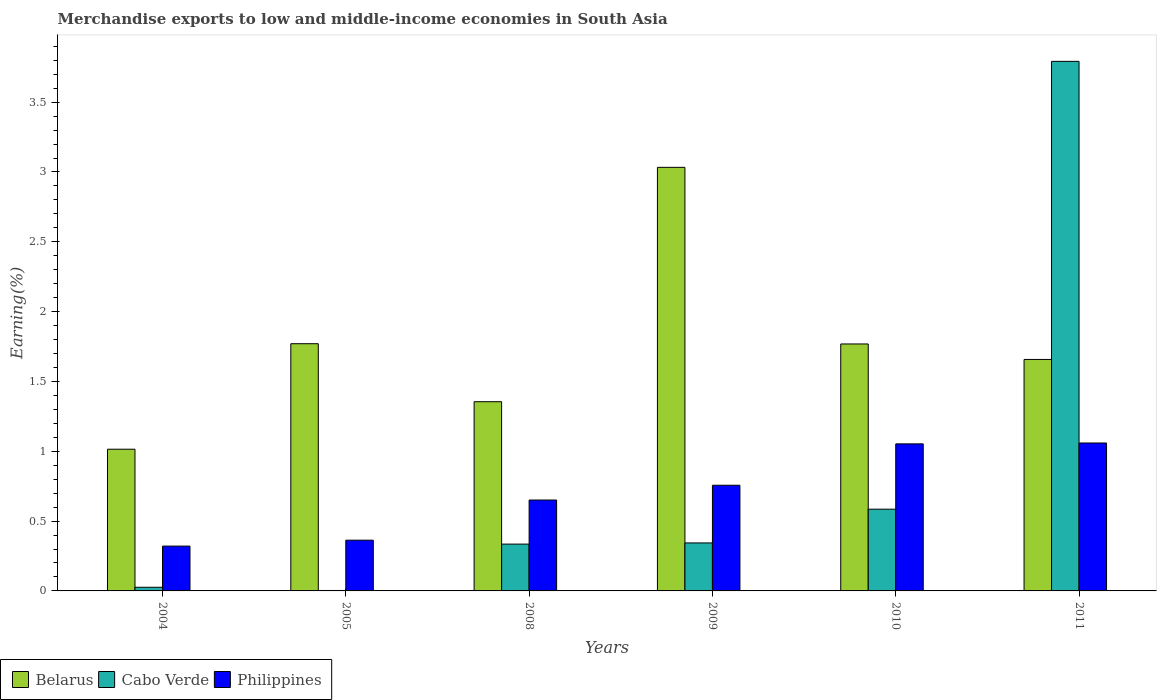How many different coloured bars are there?
Your answer should be compact. 3. Are the number of bars on each tick of the X-axis equal?
Provide a short and direct response. Yes. How many bars are there on the 1st tick from the right?
Provide a short and direct response. 3. In how many cases, is the number of bars for a given year not equal to the number of legend labels?
Make the answer very short. 0. What is the percentage of amount earned from merchandise exports in Cabo Verde in 2008?
Your answer should be very brief. 0.34. Across all years, what is the maximum percentage of amount earned from merchandise exports in Philippines?
Provide a succinct answer. 1.06. Across all years, what is the minimum percentage of amount earned from merchandise exports in Belarus?
Your response must be concise. 1.01. In which year was the percentage of amount earned from merchandise exports in Belarus maximum?
Your answer should be compact. 2009. What is the total percentage of amount earned from merchandise exports in Philippines in the graph?
Ensure brevity in your answer.  4.2. What is the difference between the percentage of amount earned from merchandise exports in Belarus in 2008 and that in 2009?
Provide a succinct answer. -1.68. What is the difference between the percentage of amount earned from merchandise exports in Belarus in 2009 and the percentage of amount earned from merchandise exports in Philippines in 2004?
Keep it short and to the point. 2.71. What is the average percentage of amount earned from merchandise exports in Cabo Verde per year?
Keep it short and to the point. 0.85. In the year 2011, what is the difference between the percentage of amount earned from merchandise exports in Cabo Verde and percentage of amount earned from merchandise exports in Belarus?
Your response must be concise. 2.13. In how many years, is the percentage of amount earned from merchandise exports in Philippines greater than 2.4 %?
Provide a short and direct response. 0. What is the ratio of the percentage of amount earned from merchandise exports in Philippines in 2008 to that in 2011?
Provide a short and direct response. 0.61. Is the difference between the percentage of amount earned from merchandise exports in Cabo Verde in 2005 and 2008 greater than the difference between the percentage of amount earned from merchandise exports in Belarus in 2005 and 2008?
Provide a succinct answer. No. What is the difference between the highest and the second highest percentage of amount earned from merchandise exports in Philippines?
Provide a succinct answer. 0.01. What is the difference between the highest and the lowest percentage of amount earned from merchandise exports in Belarus?
Your answer should be very brief. 2.02. What does the 2nd bar from the left in 2009 represents?
Ensure brevity in your answer.  Cabo Verde. What does the 2nd bar from the right in 2004 represents?
Make the answer very short. Cabo Verde. Is it the case that in every year, the sum of the percentage of amount earned from merchandise exports in Philippines and percentage of amount earned from merchandise exports in Cabo Verde is greater than the percentage of amount earned from merchandise exports in Belarus?
Keep it short and to the point. No. How many bars are there?
Your response must be concise. 18. How many years are there in the graph?
Provide a succinct answer. 6. Does the graph contain any zero values?
Make the answer very short. No. Where does the legend appear in the graph?
Your response must be concise. Bottom left. What is the title of the graph?
Make the answer very short. Merchandise exports to low and middle-income economies in South Asia. Does "Jamaica" appear as one of the legend labels in the graph?
Give a very brief answer. No. What is the label or title of the X-axis?
Your answer should be very brief. Years. What is the label or title of the Y-axis?
Keep it short and to the point. Earning(%). What is the Earning(%) of Belarus in 2004?
Ensure brevity in your answer.  1.01. What is the Earning(%) of Cabo Verde in 2004?
Your answer should be very brief. 0.03. What is the Earning(%) of Philippines in 2004?
Give a very brief answer. 0.32. What is the Earning(%) in Belarus in 2005?
Offer a very short reply. 1.77. What is the Earning(%) of Cabo Verde in 2005?
Make the answer very short. 0. What is the Earning(%) of Philippines in 2005?
Give a very brief answer. 0.36. What is the Earning(%) in Belarus in 2008?
Ensure brevity in your answer.  1.35. What is the Earning(%) in Cabo Verde in 2008?
Provide a succinct answer. 0.34. What is the Earning(%) in Philippines in 2008?
Provide a succinct answer. 0.65. What is the Earning(%) in Belarus in 2009?
Your answer should be very brief. 3.03. What is the Earning(%) of Cabo Verde in 2009?
Give a very brief answer. 0.34. What is the Earning(%) of Philippines in 2009?
Make the answer very short. 0.76. What is the Earning(%) of Belarus in 2010?
Offer a terse response. 1.77. What is the Earning(%) in Cabo Verde in 2010?
Your answer should be very brief. 0.59. What is the Earning(%) in Philippines in 2010?
Your response must be concise. 1.05. What is the Earning(%) of Belarus in 2011?
Offer a very short reply. 1.66. What is the Earning(%) of Cabo Verde in 2011?
Keep it short and to the point. 3.79. What is the Earning(%) in Philippines in 2011?
Keep it short and to the point. 1.06. Across all years, what is the maximum Earning(%) of Belarus?
Offer a very short reply. 3.03. Across all years, what is the maximum Earning(%) of Cabo Verde?
Provide a succinct answer. 3.79. Across all years, what is the maximum Earning(%) in Philippines?
Ensure brevity in your answer.  1.06. Across all years, what is the minimum Earning(%) of Belarus?
Keep it short and to the point. 1.01. Across all years, what is the minimum Earning(%) of Cabo Verde?
Provide a succinct answer. 0. Across all years, what is the minimum Earning(%) of Philippines?
Keep it short and to the point. 0.32. What is the total Earning(%) in Belarus in the graph?
Make the answer very short. 10.6. What is the total Earning(%) of Cabo Verde in the graph?
Your response must be concise. 5.09. What is the total Earning(%) of Philippines in the graph?
Give a very brief answer. 4.2. What is the difference between the Earning(%) of Belarus in 2004 and that in 2005?
Your answer should be very brief. -0.76. What is the difference between the Earning(%) in Cabo Verde in 2004 and that in 2005?
Give a very brief answer. 0.02. What is the difference between the Earning(%) of Philippines in 2004 and that in 2005?
Your answer should be compact. -0.04. What is the difference between the Earning(%) of Belarus in 2004 and that in 2008?
Offer a terse response. -0.34. What is the difference between the Earning(%) in Cabo Verde in 2004 and that in 2008?
Provide a short and direct response. -0.31. What is the difference between the Earning(%) in Philippines in 2004 and that in 2008?
Your response must be concise. -0.33. What is the difference between the Earning(%) of Belarus in 2004 and that in 2009?
Give a very brief answer. -2.02. What is the difference between the Earning(%) in Cabo Verde in 2004 and that in 2009?
Provide a short and direct response. -0.32. What is the difference between the Earning(%) of Philippines in 2004 and that in 2009?
Offer a terse response. -0.44. What is the difference between the Earning(%) in Belarus in 2004 and that in 2010?
Your answer should be very brief. -0.75. What is the difference between the Earning(%) of Cabo Verde in 2004 and that in 2010?
Provide a succinct answer. -0.56. What is the difference between the Earning(%) in Philippines in 2004 and that in 2010?
Give a very brief answer. -0.73. What is the difference between the Earning(%) in Belarus in 2004 and that in 2011?
Ensure brevity in your answer.  -0.64. What is the difference between the Earning(%) of Cabo Verde in 2004 and that in 2011?
Your answer should be compact. -3.77. What is the difference between the Earning(%) of Philippines in 2004 and that in 2011?
Your response must be concise. -0.74. What is the difference between the Earning(%) in Belarus in 2005 and that in 2008?
Offer a very short reply. 0.42. What is the difference between the Earning(%) in Cabo Verde in 2005 and that in 2008?
Make the answer very short. -0.33. What is the difference between the Earning(%) in Philippines in 2005 and that in 2008?
Provide a short and direct response. -0.29. What is the difference between the Earning(%) in Belarus in 2005 and that in 2009?
Give a very brief answer. -1.26. What is the difference between the Earning(%) in Cabo Verde in 2005 and that in 2009?
Your answer should be compact. -0.34. What is the difference between the Earning(%) of Philippines in 2005 and that in 2009?
Ensure brevity in your answer.  -0.39. What is the difference between the Earning(%) in Belarus in 2005 and that in 2010?
Offer a very short reply. 0. What is the difference between the Earning(%) of Cabo Verde in 2005 and that in 2010?
Keep it short and to the point. -0.58. What is the difference between the Earning(%) in Philippines in 2005 and that in 2010?
Give a very brief answer. -0.69. What is the difference between the Earning(%) of Belarus in 2005 and that in 2011?
Ensure brevity in your answer.  0.11. What is the difference between the Earning(%) in Cabo Verde in 2005 and that in 2011?
Give a very brief answer. -3.79. What is the difference between the Earning(%) in Philippines in 2005 and that in 2011?
Provide a short and direct response. -0.7. What is the difference between the Earning(%) of Belarus in 2008 and that in 2009?
Offer a terse response. -1.68. What is the difference between the Earning(%) in Cabo Verde in 2008 and that in 2009?
Your answer should be compact. -0.01. What is the difference between the Earning(%) of Philippines in 2008 and that in 2009?
Provide a succinct answer. -0.11. What is the difference between the Earning(%) of Belarus in 2008 and that in 2010?
Give a very brief answer. -0.41. What is the difference between the Earning(%) in Cabo Verde in 2008 and that in 2010?
Provide a succinct answer. -0.25. What is the difference between the Earning(%) of Philippines in 2008 and that in 2010?
Give a very brief answer. -0.4. What is the difference between the Earning(%) of Belarus in 2008 and that in 2011?
Offer a terse response. -0.3. What is the difference between the Earning(%) of Cabo Verde in 2008 and that in 2011?
Make the answer very short. -3.46. What is the difference between the Earning(%) in Philippines in 2008 and that in 2011?
Provide a short and direct response. -0.41. What is the difference between the Earning(%) in Belarus in 2009 and that in 2010?
Your response must be concise. 1.26. What is the difference between the Earning(%) in Cabo Verde in 2009 and that in 2010?
Provide a succinct answer. -0.24. What is the difference between the Earning(%) of Philippines in 2009 and that in 2010?
Ensure brevity in your answer.  -0.3. What is the difference between the Earning(%) of Belarus in 2009 and that in 2011?
Make the answer very short. 1.38. What is the difference between the Earning(%) of Cabo Verde in 2009 and that in 2011?
Your response must be concise. -3.45. What is the difference between the Earning(%) of Philippines in 2009 and that in 2011?
Your response must be concise. -0.3. What is the difference between the Earning(%) in Belarus in 2010 and that in 2011?
Your answer should be very brief. 0.11. What is the difference between the Earning(%) of Cabo Verde in 2010 and that in 2011?
Your answer should be compact. -3.21. What is the difference between the Earning(%) in Philippines in 2010 and that in 2011?
Make the answer very short. -0.01. What is the difference between the Earning(%) in Belarus in 2004 and the Earning(%) in Cabo Verde in 2005?
Your answer should be very brief. 1.01. What is the difference between the Earning(%) in Belarus in 2004 and the Earning(%) in Philippines in 2005?
Offer a very short reply. 0.65. What is the difference between the Earning(%) of Cabo Verde in 2004 and the Earning(%) of Philippines in 2005?
Provide a short and direct response. -0.34. What is the difference between the Earning(%) in Belarus in 2004 and the Earning(%) in Cabo Verde in 2008?
Ensure brevity in your answer.  0.68. What is the difference between the Earning(%) of Belarus in 2004 and the Earning(%) of Philippines in 2008?
Offer a very short reply. 0.36. What is the difference between the Earning(%) in Cabo Verde in 2004 and the Earning(%) in Philippines in 2008?
Provide a short and direct response. -0.62. What is the difference between the Earning(%) in Belarus in 2004 and the Earning(%) in Cabo Verde in 2009?
Your response must be concise. 0.67. What is the difference between the Earning(%) of Belarus in 2004 and the Earning(%) of Philippines in 2009?
Your answer should be very brief. 0.26. What is the difference between the Earning(%) of Cabo Verde in 2004 and the Earning(%) of Philippines in 2009?
Offer a very short reply. -0.73. What is the difference between the Earning(%) of Belarus in 2004 and the Earning(%) of Cabo Verde in 2010?
Provide a succinct answer. 0.43. What is the difference between the Earning(%) in Belarus in 2004 and the Earning(%) in Philippines in 2010?
Keep it short and to the point. -0.04. What is the difference between the Earning(%) of Cabo Verde in 2004 and the Earning(%) of Philippines in 2010?
Your response must be concise. -1.03. What is the difference between the Earning(%) in Belarus in 2004 and the Earning(%) in Cabo Verde in 2011?
Provide a succinct answer. -2.78. What is the difference between the Earning(%) of Belarus in 2004 and the Earning(%) of Philippines in 2011?
Give a very brief answer. -0.04. What is the difference between the Earning(%) in Cabo Verde in 2004 and the Earning(%) in Philippines in 2011?
Offer a terse response. -1.03. What is the difference between the Earning(%) in Belarus in 2005 and the Earning(%) in Cabo Verde in 2008?
Your answer should be compact. 1.44. What is the difference between the Earning(%) of Belarus in 2005 and the Earning(%) of Philippines in 2008?
Provide a short and direct response. 1.12. What is the difference between the Earning(%) in Cabo Verde in 2005 and the Earning(%) in Philippines in 2008?
Offer a terse response. -0.65. What is the difference between the Earning(%) of Belarus in 2005 and the Earning(%) of Cabo Verde in 2009?
Keep it short and to the point. 1.43. What is the difference between the Earning(%) of Belarus in 2005 and the Earning(%) of Philippines in 2009?
Ensure brevity in your answer.  1.01. What is the difference between the Earning(%) in Cabo Verde in 2005 and the Earning(%) in Philippines in 2009?
Your response must be concise. -0.75. What is the difference between the Earning(%) in Belarus in 2005 and the Earning(%) in Cabo Verde in 2010?
Ensure brevity in your answer.  1.19. What is the difference between the Earning(%) in Belarus in 2005 and the Earning(%) in Philippines in 2010?
Provide a short and direct response. 0.72. What is the difference between the Earning(%) of Cabo Verde in 2005 and the Earning(%) of Philippines in 2010?
Provide a short and direct response. -1.05. What is the difference between the Earning(%) of Belarus in 2005 and the Earning(%) of Cabo Verde in 2011?
Give a very brief answer. -2.02. What is the difference between the Earning(%) in Belarus in 2005 and the Earning(%) in Philippines in 2011?
Offer a terse response. 0.71. What is the difference between the Earning(%) of Cabo Verde in 2005 and the Earning(%) of Philippines in 2011?
Provide a succinct answer. -1.06. What is the difference between the Earning(%) of Belarus in 2008 and the Earning(%) of Cabo Verde in 2009?
Ensure brevity in your answer.  1.01. What is the difference between the Earning(%) of Belarus in 2008 and the Earning(%) of Philippines in 2009?
Make the answer very short. 0.6. What is the difference between the Earning(%) in Cabo Verde in 2008 and the Earning(%) in Philippines in 2009?
Give a very brief answer. -0.42. What is the difference between the Earning(%) in Belarus in 2008 and the Earning(%) in Cabo Verde in 2010?
Your answer should be compact. 0.77. What is the difference between the Earning(%) in Belarus in 2008 and the Earning(%) in Philippines in 2010?
Keep it short and to the point. 0.3. What is the difference between the Earning(%) of Cabo Verde in 2008 and the Earning(%) of Philippines in 2010?
Offer a terse response. -0.72. What is the difference between the Earning(%) of Belarus in 2008 and the Earning(%) of Cabo Verde in 2011?
Your answer should be very brief. -2.44. What is the difference between the Earning(%) in Belarus in 2008 and the Earning(%) in Philippines in 2011?
Provide a short and direct response. 0.3. What is the difference between the Earning(%) in Cabo Verde in 2008 and the Earning(%) in Philippines in 2011?
Provide a succinct answer. -0.72. What is the difference between the Earning(%) in Belarus in 2009 and the Earning(%) in Cabo Verde in 2010?
Make the answer very short. 2.45. What is the difference between the Earning(%) in Belarus in 2009 and the Earning(%) in Philippines in 2010?
Make the answer very short. 1.98. What is the difference between the Earning(%) in Cabo Verde in 2009 and the Earning(%) in Philippines in 2010?
Ensure brevity in your answer.  -0.71. What is the difference between the Earning(%) of Belarus in 2009 and the Earning(%) of Cabo Verde in 2011?
Provide a succinct answer. -0.76. What is the difference between the Earning(%) of Belarus in 2009 and the Earning(%) of Philippines in 2011?
Offer a very short reply. 1.97. What is the difference between the Earning(%) in Cabo Verde in 2009 and the Earning(%) in Philippines in 2011?
Offer a very short reply. -0.72. What is the difference between the Earning(%) of Belarus in 2010 and the Earning(%) of Cabo Verde in 2011?
Give a very brief answer. -2.02. What is the difference between the Earning(%) of Belarus in 2010 and the Earning(%) of Philippines in 2011?
Your answer should be very brief. 0.71. What is the difference between the Earning(%) of Cabo Verde in 2010 and the Earning(%) of Philippines in 2011?
Your answer should be compact. -0.47. What is the average Earning(%) of Belarus per year?
Your answer should be very brief. 1.77. What is the average Earning(%) of Cabo Verde per year?
Provide a succinct answer. 0.85. What is the average Earning(%) in Philippines per year?
Offer a terse response. 0.7. In the year 2004, what is the difference between the Earning(%) in Belarus and Earning(%) in Cabo Verde?
Provide a short and direct response. 0.99. In the year 2004, what is the difference between the Earning(%) in Belarus and Earning(%) in Philippines?
Your answer should be compact. 0.69. In the year 2004, what is the difference between the Earning(%) of Cabo Verde and Earning(%) of Philippines?
Give a very brief answer. -0.29. In the year 2005, what is the difference between the Earning(%) of Belarus and Earning(%) of Cabo Verde?
Make the answer very short. 1.77. In the year 2005, what is the difference between the Earning(%) of Belarus and Earning(%) of Philippines?
Your answer should be very brief. 1.41. In the year 2005, what is the difference between the Earning(%) in Cabo Verde and Earning(%) in Philippines?
Your response must be concise. -0.36. In the year 2008, what is the difference between the Earning(%) of Belarus and Earning(%) of Cabo Verde?
Offer a terse response. 1.02. In the year 2008, what is the difference between the Earning(%) of Belarus and Earning(%) of Philippines?
Offer a very short reply. 0.7. In the year 2008, what is the difference between the Earning(%) in Cabo Verde and Earning(%) in Philippines?
Keep it short and to the point. -0.32. In the year 2009, what is the difference between the Earning(%) in Belarus and Earning(%) in Cabo Verde?
Provide a short and direct response. 2.69. In the year 2009, what is the difference between the Earning(%) in Belarus and Earning(%) in Philippines?
Offer a terse response. 2.28. In the year 2009, what is the difference between the Earning(%) of Cabo Verde and Earning(%) of Philippines?
Your answer should be compact. -0.41. In the year 2010, what is the difference between the Earning(%) of Belarus and Earning(%) of Cabo Verde?
Your answer should be compact. 1.18. In the year 2010, what is the difference between the Earning(%) in Belarus and Earning(%) in Philippines?
Provide a succinct answer. 0.72. In the year 2010, what is the difference between the Earning(%) in Cabo Verde and Earning(%) in Philippines?
Offer a very short reply. -0.47. In the year 2011, what is the difference between the Earning(%) of Belarus and Earning(%) of Cabo Verde?
Your answer should be compact. -2.13. In the year 2011, what is the difference between the Earning(%) of Belarus and Earning(%) of Philippines?
Make the answer very short. 0.6. In the year 2011, what is the difference between the Earning(%) in Cabo Verde and Earning(%) in Philippines?
Provide a short and direct response. 2.73. What is the ratio of the Earning(%) in Belarus in 2004 to that in 2005?
Ensure brevity in your answer.  0.57. What is the ratio of the Earning(%) in Cabo Verde in 2004 to that in 2005?
Make the answer very short. 8.24. What is the ratio of the Earning(%) of Philippines in 2004 to that in 2005?
Make the answer very short. 0.88. What is the ratio of the Earning(%) in Belarus in 2004 to that in 2008?
Offer a very short reply. 0.75. What is the ratio of the Earning(%) in Cabo Verde in 2004 to that in 2008?
Make the answer very short. 0.08. What is the ratio of the Earning(%) of Philippines in 2004 to that in 2008?
Give a very brief answer. 0.49. What is the ratio of the Earning(%) in Belarus in 2004 to that in 2009?
Offer a very short reply. 0.33. What is the ratio of the Earning(%) in Cabo Verde in 2004 to that in 2009?
Provide a succinct answer. 0.08. What is the ratio of the Earning(%) of Philippines in 2004 to that in 2009?
Ensure brevity in your answer.  0.42. What is the ratio of the Earning(%) of Belarus in 2004 to that in 2010?
Offer a terse response. 0.57. What is the ratio of the Earning(%) in Cabo Verde in 2004 to that in 2010?
Your answer should be compact. 0.04. What is the ratio of the Earning(%) in Philippines in 2004 to that in 2010?
Provide a succinct answer. 0.3. What is the ratio of the Earning(%) in Belarus in 2004 to that in 2011?
Offer a very short reply. 0.61. What is the ratio of the Earning(%) in Cabo Verde in 2004 to that in 2011?
Your answer should be compact. 0.01. What is the ratio of the Earning(%) of Philippines in 2004 to that in 2011?
Your answer should be very brief. 0.3. What is the ratio of the Earning(%) of Belarus in 2005 to that in 2008?
Give a very brief answer. 1.31. What is the ratio of the Earning(%) of Cabo Verde in 2005 to that in 2008?
Your answer should be very brief. 0.01. What is the ratio of the Earning(%) in Philippines in 2005 to that in 2008?
Make the answer very short. 0.56. What is the ratio of the Earning(%) of Belarus in 2005 to that in 2009?
Provide a short and direct response. 0.58. What is the ratio of the Earning(%) of Cabo Verde in 2005 to that in 2009?
Give a very brief answer. 0.01. What is the ratio of the Earning(%) in Philippines in 2005 to that in 2009?
Make the answer very short. 0.48. What is the ratio of the Earning(%) of Cabo Verde in 2005 to that in 2010?
Your answer should be compact. 0.01. What is the ratio of the Earning(%) of Philippines in 2005 to that in 2010?
Make the answer very short. 0.34. What is the ratio of the Earning(%) in Belarus in 2005 to that in 2011?
Offer a very short reply. 1.07. What is the ratio of the Earning(%) of Cabo Verde in 2005 to that in 2011?
Offer a terse response. 0. What is the ratio of the Earning(%) in Philippines in 2005 to that in 2011?
Your answer should be compact. 0.34. What is the ratio of the Earning(%) of Belarus in 2008 to that in 2009?
Give a very brief answer. 0.45. What is the ratio of the Earning(%) of Cabo Verde in 2008 to that in 2009?
Offer a terse response. 0.98. What is the ratio of the Earning(%) in Philippines in 2008 to that in 2009?
Your response must be concise. 0.86. What is the ratio of the Earning(%) in Belarus in 2008 to that in 2010?
Provide a short and direct response. 0.77. What is the ratio of the Earning(%) in Cabo Verde in 2008 to that in 2010?
Keep it short and to the point. 0.57. What is the ratio of the Earning(%) in Philippines in 2008 to that in 2010?
Offer a terse response. 0.62. What is the ratio of the Earning(%) of Belarus in 2008 to that in 2011?
Ensure brevity in your answer.  0.82. What is the ratio of the Earning(%) of Cabo Verde in 2008 to that in 2011?
Provide a succinct answer. 0.09. What is the ratio of the Earning(%) in Philippines in 2008 to that in 2011?
Offer a very short reply. 0.61. What is the ratio of the Earning(%) in Belarus in 2009 to that in 2010?
Keep it short and to the point. 1.72. What is the ratio of the Earning(%) of Cabo Verde in 2009 to that in 2010?
Your answer should be compact. 0.59. What is the ratio of the Earning(%) in Philippines in 2009 to that in 2010?
Provide a short and direct response. 0.72. What is the ratio of the Earning(%) of Belarus in 2009 to that in 2011?
Offer a very short reply. 1.83. What is the ratio of the Earning(%) of Cabo Verde in 2009 to that in 2011?
Ensure brevity in your answer.  0.09. What is the ratio of the Earning(%) in Philippines in 2009 to that in 2011?
Offer a terse response. 0.71. What is the ratio of the Earning(%) of Belarus in 2010 to that in 2011?
Your answer should be compact. 1.07. What is the ratio of the Earning(%) of Cabo Verde in 2010 to that in 2011?
Offer a terse response. 0.15. What is the ratio of the Earning(%) of Philippines in 2010 to that in 2011?
Your response must be concise. 0.99. What is the difference between the highest and the second highest Earning(%) of Belarus?
Offer a terse response. 1.26. What is the difference between the highest and the second highest Earning(%) of Cabo Verde?
Ensure brevity in your answer.  3.21. What is the difference between the highest and the second highest Earning(%) of Philippines?
Give a very brief answer. 0.01. What is the difference between the highest and the lowest Earning(%) of Belarus?
Offer a very short reply. 2.02. What is the difference between the highest and the lowest Earning(%) in Cabo Verde?
Ensure brevity in your answer.  3.79. What is the difference between the highest and the lowest Earning(%) in Philippines?
Provide a short and direct response. 0.74. 